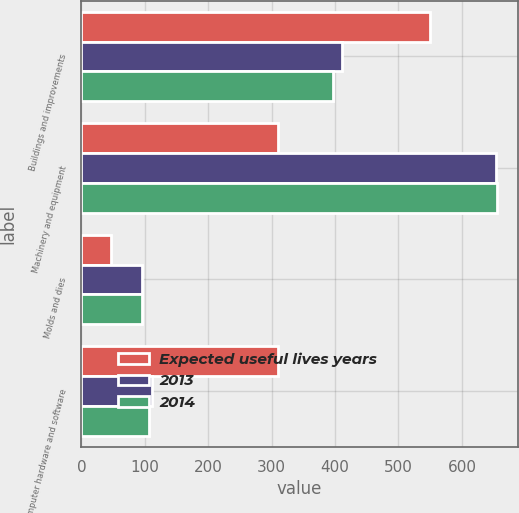<chart> <loc_0><loc_0><loc_500><loc_500><stacked_bar_chart><ecel><fcel>Buildings and improvements<fcel>Machinery and equipment<fcel>Molds and dies<fcel>Computer hardware and software<nl><fcel>Expected useful lives years<fcel>550<fcel>310<fcel>47<fcel>310<nl><fcel>2013<fcel>410.6<fcel>654.1<fcel>94.8<fcel>111.3<nl><fcel>2014<fcel>397.5<fcel>655.2<fcel>95.7<fcel>107.1<nl></chart> 